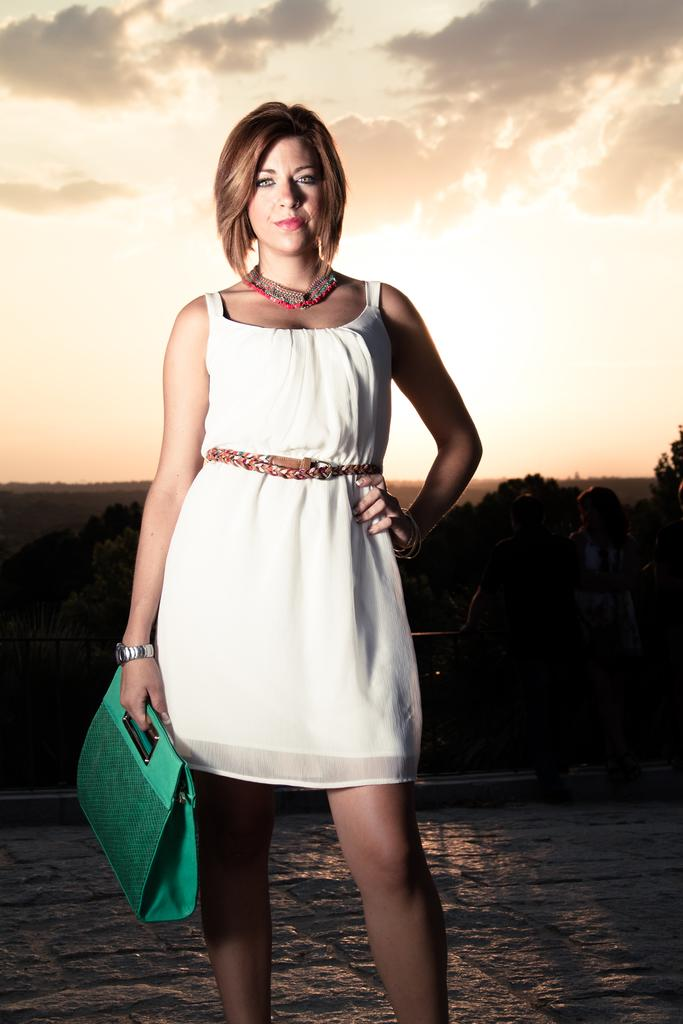Who is the main subject in the image? There is a woman in the image. What is the woman holding in the image? The woman is holding a green handbag. What can be seen in the background of the image? There are trees in the background of the image. What is visible at the top of the image? The sky is visible at the top of the image. What type of caption is written on the woman's shirt in the image? There is no caption visible on the woman's shirt in the image. Can you see any steam coming from the trees in the background? There is no steam present in the image; only trees and the sky are visible in the background. 